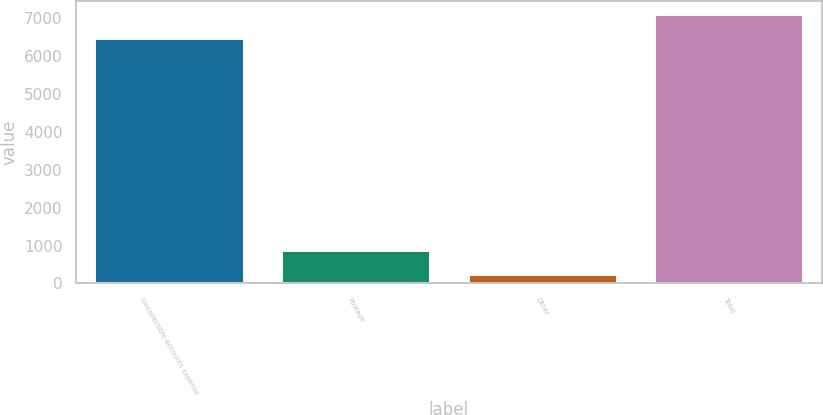Convert chart to OTSL. <chart><loc_0><loc_0><loc_500><loc_500><bar_chart><fcel>Uncollectible accounts expense<fcel>Postage<fcel>Other<fcel>Total<nl><fcel>6467<fcel>873.1<fcel>244<fcel>7096.1<nl></chart> 